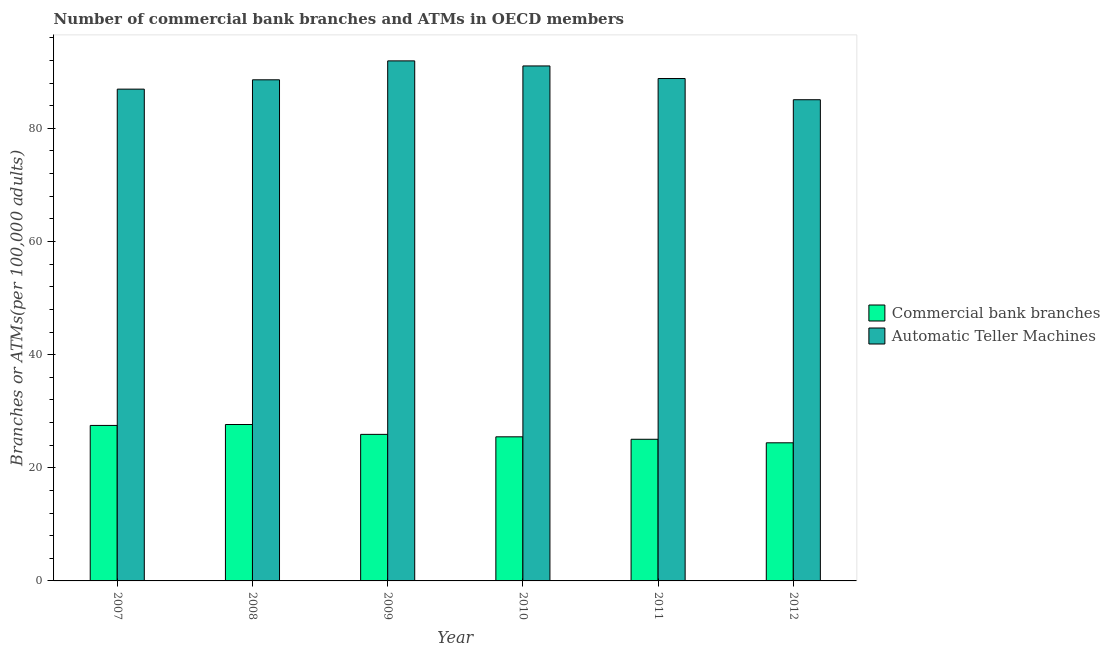How many bars are there on the 4th tick from the left?
Your answer should be compact. 2. What is the number of atms in 2010?
Provide a succinct answer. 91.03. Across all years, what is the maximum number of commercal bank branches?
Ensure brevity in your answer.  27.65. Across all years, what is the minimum number of commercal bank branches?
Provide a short and direct response. 24.41. In which year was the number of atms minimum?
Your response must be concise. 2012. What is the total number of atms in the graph?
Provide a short and direct response. 532.33. What is the difference between the number of commercal bank branches in 2008 and that in 2010?
Your answer should be very brief. 2.18. What is the difference between the number of atms in 2011 and the number of commercal bank branches in 2008?
Offer a terse response. 0.23. What is the average number of atms per year?
Keep it short and to the point. 88.72. In the year 2009, what is the difference between the number of commercal bank branches and number of atms?
Offer a terse response. 0. What is the ratio of the number of atms in 2008 to that in 2009?
Give a very brief answer. 0.96. What is the difference between the highest and the second highest number of commercal bank branches?
Your answer should be very brief. 0.16. What is the difference between the highest and the lowest number of commercal bank branches?
Your answer should be very brief. 3.23. Is the sum of the number of atms in 2008 and 2010 greater than the maximum number of commercal bank branches across all years?
Make the answer very short. Yes. What does the 2nd bar from the left in 2009 represents?
Offer a terse response. Automatic Teller Machines. What does the 1st bar from the right in 2010 represents?
Your answer should be compact. Automatic Teller Machines. What is the difference between two consecutive major ticks on the Y-axis?
Offer a very short reply. 20. Are the values on the major ticks of Y-axis written in scientific E-notation?
Your response must be concise. No. Does the graph contain any zero values?
Offer a terse response. No. Where does the legend appear in the graph?
Provide a succinct answer. Center right. How are the legend labels stacked?
Your response must be concise. Vertical. What is the title of the graph?
Give a very brief answer. Number of commercial bank branches and ATMs in OECD members. Does "Electricity" appear as one of the legend labels in the graph?
Provide a short and direct response. No. What is the label or title of the X-axis?
Ensure brevity in your answer.  Year. What is the label or title of the Y-axis?
Your response must be concise. Branches or ATMs(per 100,0 adults). What is the Branches or ATMs(per 100,000 adults) of Commercial bank branches in 2007?
Make the answer very short. 27.48. What is the Branches or ATMs(per 100,000 adults) in Automatic Teller Machines in 2007?
Provide a short and direct response. 86.93. What is the Branches or ATMs(per 100,000 adults) of Commercial bank branches in 2008?
Make the answer very short. 27.65. What is the Branches or ATMs(per 100,000 adults) of Automatic Teller Machines in 2008?
Your answer should be compact. 88.58. What is the Branches or ATMs(per 100,000 adults) of Commercial bank branches in 2009?
Make the answer very short. 25.9. What is the Branches or ATMs(per 100,000 adults) in Automatic Teller Machines in 2009?
Ensure brevity in your answer.  91.92. What is the Branches or ATMs(per 100,000 adults) of Commercial bank branches in 2010?
Your answer should be very brief. 25.47. What is the Branches or ATMs(per 100,000 adults) of Automatic Teller Machines in 2010?
Provide a succinct answer. 91.03. What is the Branches or ATMs(per 100,000 adults) in Commercial bank branches in 2011?
Your response must be concise. 25.04. What is the Branches or ATMs(per 100,000 adults) in Automatic Teller Machines in 2011?
Make the answer very short. 88.81. What is the Branches or ATMs(per 100,000 adults) in Commercial bank branches in 2012?
Your response must be concise. 24.41. What is the Branches or ATMs(per 100,000 adults) of Automatic Teller Machines in 2012?
Your answer should be compact. 85.06. Across all years, what is the maximum Branches or ATMs(per 100,000 adults) of Commercial bank branches?
Offer a terse response. 27.65. Across all years, what is the maximum Branches or ATMs(per 100,000 adults) of Automatic Teller Machines?
Keep it short and to the point. 91.92. Across all years, what is the minimum Branches or ATMs(per 100,000 adults) in Commercial bank branches?
Make the answer very short. 24.41. Across all years, what is the minimum Branches or ATMs(per 100,000 adults) of Automatic Teller Machines?
Ensure brevity in your answer.  85.06. What is the total Branches or ATMs(per 100,000 adults) in Commercial bank branches in the graph?
Your answer should be very brief. 155.96. What is the total Branches or ATMs(per 100,000 adults) of Automatic Teller Machines in the graph?
Offer a very short reply. 532.33. What is the difference between the Branches or ATMs(per 100,000 adults) in Commercial bank branches in 2007 and that in 2008?
Keep it short and to the point. -0.16. What is the difference between the Branches or ATMs(per 100,000 adults) of Automatic Teller Machines in 2007 and that in 2008?
Provide a succinct answer. -1.65. What is the difference between the Branches or ATMs(per 100,000 adults) in Commercial bank branches in 2007 and that in 2009?
Provide a succinct answer. 1.58. What is the difference between the Branches or ATMs(per 100,000 adults) in Automatic Teller Machines in 2007 and that in 2009?
Offer a very short reply. -4.99. What is the difference between the Branches or ATMs(per 100,000 adults) of Commercial bank branches in 2007 and that in 2010?
Your answer should be very brief. 2.01. What is the difference between the Branches or ATMs(per 100,000 adults) of Automatic Teller Machines in 2007 and that in 2010?
Make the answer very short. -4.1. What is the difference between the Branches or ATMs(per 100,000 adults) in Commercial bank branches in 2007 and that in 2011?
Make the answer very short. 2.45. What is the difference between the Branches or ATMs(per 100,000 adults) in Automatic Teller Machines in 2007 and that in 2011?
Ensure brevity in your answer.  -1.87. What is the difference between the Branches or ATMs(per 100,000 adults) of Commercial bank branches in 2007 and that in 2012?
Keep it short and to the point. 3.07. What is the difference between the Branches or ATMs(per 100,000 adults) in Automatic Teller Machines in 2007 and that in 2012?
Provide a short and direct response. 1.87. What is the difference between the Branches or ATMs(per 100,000 adults) in Commercial bank branches in 2008 and that in 2009?
Your answer should be compact. 1.74. What is the difference between the Branches or ATMs(per 100,000 adults) in Automatic Teller Machines in 2008 and that in 2009?
Offer a very short reply. -3.35. What is the difference between the Branches or ATMs(per 100,000 adults) in Commercial bank branches in 2008 and that in 2010?
Make the answer very short. 2.18. What is the difference between the Branches or ATMs(per 100,000 adults) of Automatic Teller Machines in 2008 and that in 2010?
Offer a terse response. -2.45. What is the difference between the Branches or ATMs(per 100,000 adults) of Commercial bank branches in 2008 and that in 2011?
Your response must be concise. 2.61. What is the difference between the Branches or ATMs(per 100,000 adults) in Automatic Teller Machines in 2008 and that in 2011?
Offer a terse response. -0.23. What is the difference between the Branches or ATMs(per 100,000 adults) in Commercial bank branches in 2008 and that in 2012?
Provide a succinct answer. 3.23. What is the difference between the Branches or ATMs(per 100,000 adults) of Automatic Teller Machines in 2008 and that in 2012?
Make the answer very short. 3.52. What is the difference between the Branches or ATMs(per 100,000 adults) in Commercial bank branches in 2009 and that in 2010?
Provide a short and direct response. 0.43. What is the difference between the Branches or ATMs(per 100,000 adults) in Automatic Teller Machines in 2009 and that in 2010?
Offer a terse response. 0.89. What is the difference between the Branches or ATMs(per 100,000 adults) of Commercial bank branches in 2009 and that in 2011?
Provide a succinct answer. 0.87. What is the difference between the Branches or ATMs(per 100,000 adults) of Automatic Teller Machines in 2009 and that in 2011?
Offer a very short reply. 3.12. What is the difference between the Branches or ATMs(per 100,000 adults) in Commercial bank branches in 2009 and that in 2012?
Offer a very short reply. 1.49. What is the difference between the Branches or ATMs(per 100,000 adults) of Automatic Teller Machines in 2009 and that in 2012?
Give a very brief answer. 6.87. What is the difference between the Branches or ATMs(per 100,000 adults) in Commercial bank branches in 2010 and that in 2011?
Your answer should be compact. 0.43. What is the difference between the Branches or ATMs(per 100,000 adults) in Automatic Teller Machines in 2010 and that in 2011?
Offer a terse response. 2.22. What is the difference between the Branches or ATMs(per 100,000 adults) in Commercial bank branches in 2010 and that in 2012?
Offer a very short reply. 1.06. What is the difference between the Branches or ATMs(per 100,000 adults) of Automatic Teller Machines in 2010 and that in 2012?
Make the answer very short. 5.97. What is the difference between the Branches or ATMs(per 100,000 adults) of Commercial bank branches in 2011 and that in 2012?
Make the answer very short. 0.62. What is the difference between the Branches or ATMs(per 100,000 adults) of Automatic Teller Machines in 2011 and that in 2012?
Offer a very short reply. 3.75. What is the difference between the Branches or ATMs(per 100,000 adults) in Commercial bank branches in 2007 and the Branches or ATMs(per 100,000 adults) in Automatic Teller Machines in 2008?
Provide a short and direct response. -61.09. What is the difference between the Branches or ATMs(per 100,000 adults) of Commercial bank branches in 2007 and the Branches or ATMs(per 100,000 adults) of Automatic Teller Machines in 2009?
Offer a terse response. -64.44. What is the difference between the Branches or ATMs(per 100,000 adults) of Commercial bank branches in 2007 and the Branches or ATMs(per 100,000 adults) of Automatic Teller Machines in 2010?
Offer a very short reply. -63.54. What is the difference between the Branches or ATMs(per 100,000 adults) in Commercial bank branches in 2007 and the Branches or ATMs(per 100,000 adults) in Automatic Teller Machines in 2011?
Give a very brief answer. -61.32. What is the difference between the Branches or ATMs(per 100,000 adults) of Commercial bank branches in 2007 and the Branches or ATMs(per 100,000 adults) of Automatic Teller Machines in 2012?
Your answer should be very brief. -57.57. What is the difference between the Branches or ATMs(per 100,000 adults) of Commercial bank branches in 2008 and the Branches or ATMs(per 100,000 adults) of Automatic Teller Machines in 2009?
Keep it short and to the point. -64.28. What is the difference between the Branches or ATMs(per 100,000 adults) in Commercial bank branches in 2008 and the Branches or ATMs(per 100,000 adults) in Automatic Teller Machines in 2010?
Make the answer very short. -63.38. What is the difference between the Branches or ATMs(per 100,000 adults) of Commercial bank branches in 2008 and the Branches or ATMs(per 100,000 adults) of Automatic Teller Machines in 2011?
Provide a short and direct response. -61.16. What is the difference between the Branches or ATMs(per 100,000 adults) of Commercial bank branches in 2008 and the Branches or ATMs(per 100,000 adults) of Automatic Teller Machines in 2012?
Your answer should be compact. -57.41. What is the difference between the Branches or ATMs(per 100,000 adults) of Commercial bank branches in 2009 and the Branches or ATMs(per 100,000 adults) of Automatic Teller Machines in 2010?
Give a very brief answer. -65.12. What is the difference between the Branches or ATMs(per 100,000 adults) of Commercial bank branches in 2009 and the Branches or ATMs(per 100,000 adults) of Automatic Teller Machines in 2011?
Provide a short and direct response. -62.9. What is the difference between the Branches or ATMs(per 100,000 adults) of Commercial bank branches in 2009 and the Branches or ATMs(per 100,000 adults) of Automatic Teller Machines in 2012?
Provide a short and direct response. -59.15. What is the difference between the Branches or ATMs(per 100,000 adults) of Commercial bank branches in 2010 and the Branches or ATMs(per 100,000 adults) of Automatic Teller Machines in 2011?
Your answer should be compact. -63.33. What is the difference between the Branches or ATMs(per 100,000 adults) in Commercial bank branches in 2010 and the Branches or ATMs(per 100,000 adults) in Automatic Teller Machines in 2012?
Provide a short and direct response. -59.59. What is the difference between the Branches or ATMs(per 100,000 adults) in Commercial bank branches in 2011 and the Branches or ATMs(per 100,000 adults) in Automatic Teller Machines in 2012?
Offer a terse response. -60.02. What is the average Branches or ATMs(per 100,000 adults) in Commercial bank branches per year?
Offer a very short reply. 25.99. What is the average Branches or ATMs(per 100,000 adults) of Automatic Teller Machines per year?
Keep it short and to the point. 88.72. In the year 2007, what is the difference between the Branches or ATMs(per 100,000 adults) of Commercial bank branches and Branches or ATMs(per 100,000 adults) of Automatic Teller Machines?
Keep it short and to the point. -59.45. In the year 2008, what is the difference between the Branches or ATMs(per 100,000 adults) in Commercial bank branches and Branches or ATMs(per 100,000 adults) in Automatic Teller Machines?
Keep it short and to the point. -60.93. In the year 2009, what is the difference between the Branches or ATMs(per 100,000 adults) in Commercial bank branches and Branches or ATMs(per 100,000 adults) in Automatic Teller Machines?
Provide a short and direct response. -66.02. In the year 2010, what is the difference between the Branches or ATMs(per 100,000 adults) of Commercial bank branches and Branches or ATMs(per 100,000 adults) of Automatic Teller Machines?
Give a very brief answer. -65.56. In the year 2011, what is the difference between the Branches or ATMs(per 100,000 adults) in Commercial bank branches and Branches or ATMs(per 100,000 adults) in Automatic Teller Machines?
Ensure brevity in your answer.  -63.77. In the year 2012, what is the difference between the Branches or ATMs(per 100,000 adults) of Commercial bank branches and Branches or ATMs(per 100,000 adults) of Automatic Teller Machines?
Make the answer very short. -60.64. What is the ratio of the Branches or ATMs(per 100,000 adults) in Commercial bank branches in 2007 to that in 2008?
Provide a short and direct response. 0.99. What is the ratio of the Branches or ATMs(per 100,000 adults) in Automatic Teller Machines in 2007 to that in 2008?
Your response must be concise. 0.98. What is the ratio of the Branches or ATMs(per 100,000 adults) of Commercial bank branches in 2007 to that in 2009?
Your answer should be compact. 1.06. What is the ratio of the Branches or ATMs(per 100,000 adults) of Automatic Teller Machines in 2007 to that in 2009?
Give a very brief answer. 0.95. What is the ratio of the Branches or ATMs(per 100,000 adults) in Commercial bank branches in 2007 to that in 2010?
Your answer should be compact. 1.08. What is the ratio of the Branches or ATMs(per 100,000 adults) of Automatic Teller Machines in 2007 to that in 2010?
Offer a very short reply. 0.95. What is the ratio of the Branches or ATMs(per 100,000 adults) in Commercial bank branches in 2007 to that in 2011?
Give a very brief answer. 1.1. What is the ratio of the Branches or ATMs(per 100,000 adults) of Automatic Teller Machines in 2007 to that in 2011?
Offer a terse response. 0.98. What is the ratio of the Branches or ATMs(per 100,000 adults) in Commercial bank branches in 2007 to that in 2012?
Give a very brief answer. 1.13. What is the ratio of the Branches or ATMs(per 100,000 adults) in Commercial bank branches in 2008 to that in 2009?
Provide a succinct answer. 1.07. What is the ratio of the Branches or ATMs(per 100,000 adults) in Automatic Teller Machines in 2008 to that in 2009?
Offer a very short reply. 0.96. What is the ratio of the Branches or ATMs(per 100,000 adults) of Commercial bank branches in 2008 to that in 2010?
Your answer should be compact. 1.09. What is the ratio of the Branches or ATMs(per 100,000 adults) of Automatic Teller Machines in 2008 to that in 2010?
Keep it short and to the point. 0.97. What is the ratio of the Branches or ATMs(per 100,000 adults) of Commercial bank branches in 2008 to that in 2011?
Offer a very short reply. 1.1. What is the ratio of the Branches or ATMs(per 100,000 adults) of Automatic Teller Machines in 2008 to that in 2011?
Ensure brevity in your answer.  1. What is the ratio of the Branches or ATMs(per 100,000 adults) in Commercial bank branches in 2008 to that in 2012?
Provide a succinct answer. 1.13. What is the ratio of the Branches or ATMs(per 100,000 adults) of Automatic Teller Machines in 2008 to that in 2012?
Provide a short and direct response. 1.04. What is the ratio of the Branches or ATMs(per 100,000 adults) of Commercial bank branches in 2009 to that in 2010?
Give a very brief answer. 1.02. What is the ratio of the Branches or ATMs(per 100,000 adults) in Automatic Teller Machines in 2009 to that in 2010?
Make the answer very short. 1.01. What is the ratio of the Branches or ATMs(per 100,000 adults) of Commercial bank branches in 2009 to that in 2011?
Provide a succinct answer. 1.03. What is the ratio of the Branches or ATMs(per 100,000 adults) of Automatic Teller Machines in 2009 to that in 2011?
Provide a short and direct response. 1.04. What is the ratio of the Branches or ATMs(per 100,000 adults) of Commercial bank branches in 2009 to that in 2012?
Provide a short and direct response. 1.06. What is the ratio of the Branches or ATMs(per 100,000 adults) in Automatic Teller Machines in 2009 to that in 2012?
Provide a short and direct response. 1.08. What is the ratio of the Branches or ATMs(per 100,000 adults) in Commercial bank branches in 2010 to that in 2011?
Offer a very short reply. 1.02. What is the ratio of the Branches or ATMs(per 100,000 adults) of Automatic Teller Machines in 2010 to that in 2011?
Offer a terse response. 1.02. What is the ratio of the Branches or ATMs(per 100,000 adults) in Commercial bank branches in 2010 to that in 2012?
Offer a terse response. 1.04. What is the ratio of the Branches or ATMs(per 100,000 adults) in Automatic Teller Machines in 2010 to that in 2012?
Your answer should be compact. 1.07. What is the ratio of the Branches or ATMs(per 100,000 adults) in Commercial bank branches in 2011 to that in 2012?
Your answer should be very brief. 1.03. What is the ratio of the Branches or ATMs(per 100,000 adults) in Automatic Teller Machines in 2011 to that in 2012?
Offer a very short reply. 1.04. What is the difference between the highest and the second highest Branches or ATMs(per 100,000 adults) in Commercial bank branches?
Your response must be concise. 0.16. What is the difference between the highest and the second highest Branches or ATMs(per 100,000 adults) in Automatic Teller Machines?
Your answer should be compact. 0.89. What is the difference between the highest and the lowest Branches or ATMs(per 100,000 adults) in Commercial bank branches?
Make the answer very short. 3.23. What is the difference between the highest and the lowest Branches or ATMs(per 100,000 adults) of Automatic Teller Machines?
Keep it short and to the point. 6.87. 